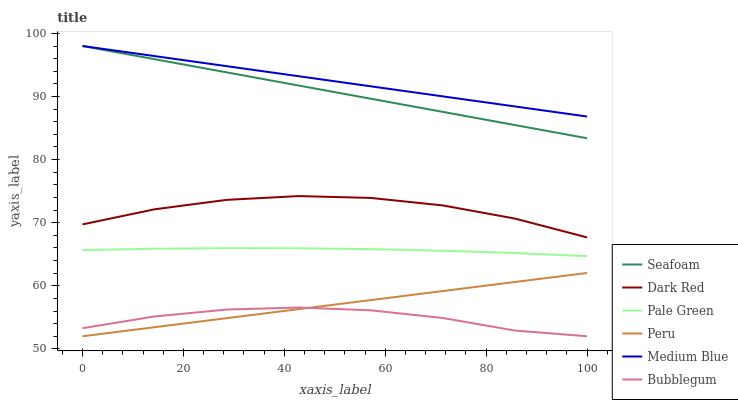Does Bubblegum have the minimum area under the curve?
Answer yes or no. Yes. Does Medium Blue have the maximum area under the curve?
Answer yes or no. Yes. Does Seafoam have the minimum area under the curve?
Answer yes or no. No. Does Seafoam have the maximum area under the curve?
Answer yes or no. No. Is Medium Blue the smoothest?
Answer yes or no. Yes. Is Dark Red the roughest?
Answer yes or no. Yes. Is Seafoam the smoothest?
Answer yes or no. No. Is Seafoam the roughest?
Answer yes or no. No. Does Bubblegum have the lowest value?
Answer yes or no. Yes. Does Seafoam have the lowest value?
Answer yes or no. No. Does Seafoam have the highest value?
Answer yes or no. Yes. Does Bubblegum have the highest value?
Answer yes or no. No. Is Dark Red less than Medium Blue?
Answer yes or no. Yes. Is Medium Blue greater than Peru?
Answer yes or no. Yes. Does Bubblegum intersect Peru?
Answer yes or no. Yes. Is Bubblegum less than Peru?
Answer yes or no. No. Is Bubblegum greater than Peru?
Answer yes or no. No. Does Dark Red intersect Medium Blue?
Answer yes or no. No. 